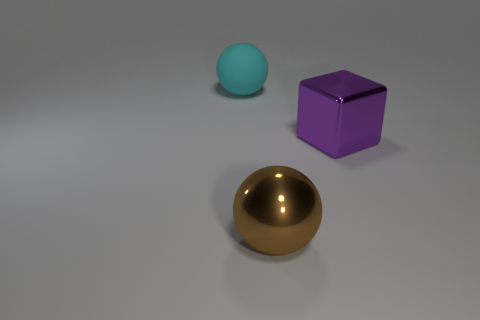There is a big metal object that is behind the sphere that is in front of the big ball that is behind the large brown shiny object; what shape is it?
Your answer should be compact. Cube. There is a block that is made of the same material as the large brown thing; what color is it?
Provide a succinct answer. Purple. What color is the big thing that is behind the big purple shiny block that is behind the brown metal thing that is in front of the big purple shiny thing?
Offer a terse response. Cyan. How many spheres are either cyan matte things or big purple objects?
Offer a very short reply. 1. There is a big rubber thing; is it the same color as the metal object that is in front of the cube?
Keep it short and to the point. No. The metallic block is what color?
Your answer should be compact. Purple. How many things are red matte cylinders or big brown metallic objects?
Ensure brevity in your answer.  1. There is another brown object that is the same size as the matte object; what material is it?
Ensure brevity in your answer.  Metal. There is a thing that is in front of the block; what size is it?
Your answer should be very brief. Large. What is the big cyan ball made of?
Your response must be concise. Rubber. 